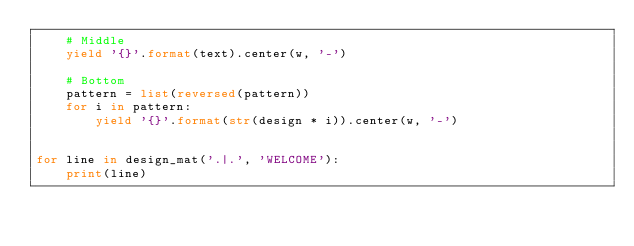Convert code to text. <code><loc_0><loc_0><loc_500><loc_500><_Python_>    # Middle
    yield '{}'.format(text).center(w, '-')

    # Bottom
    pattern = list(reversed(pattern))
    for i in pattern:
        yield '{}'.format(str(design * i)).center(w, '-')


for line in design_mat('.|.', 'WELCOME'):
    print(line)
</code> 